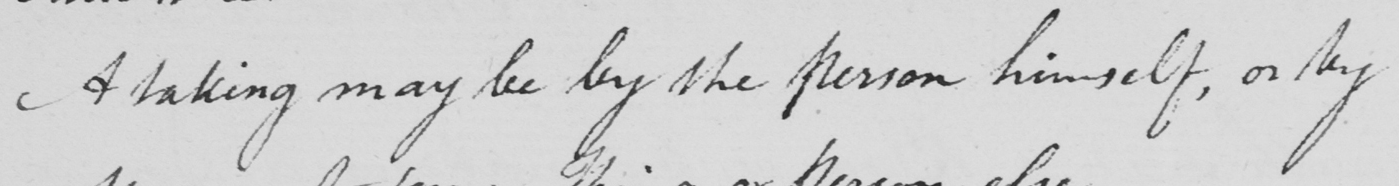Can you read and transcribe this handwriting? A taking may be by the person himself , or by 